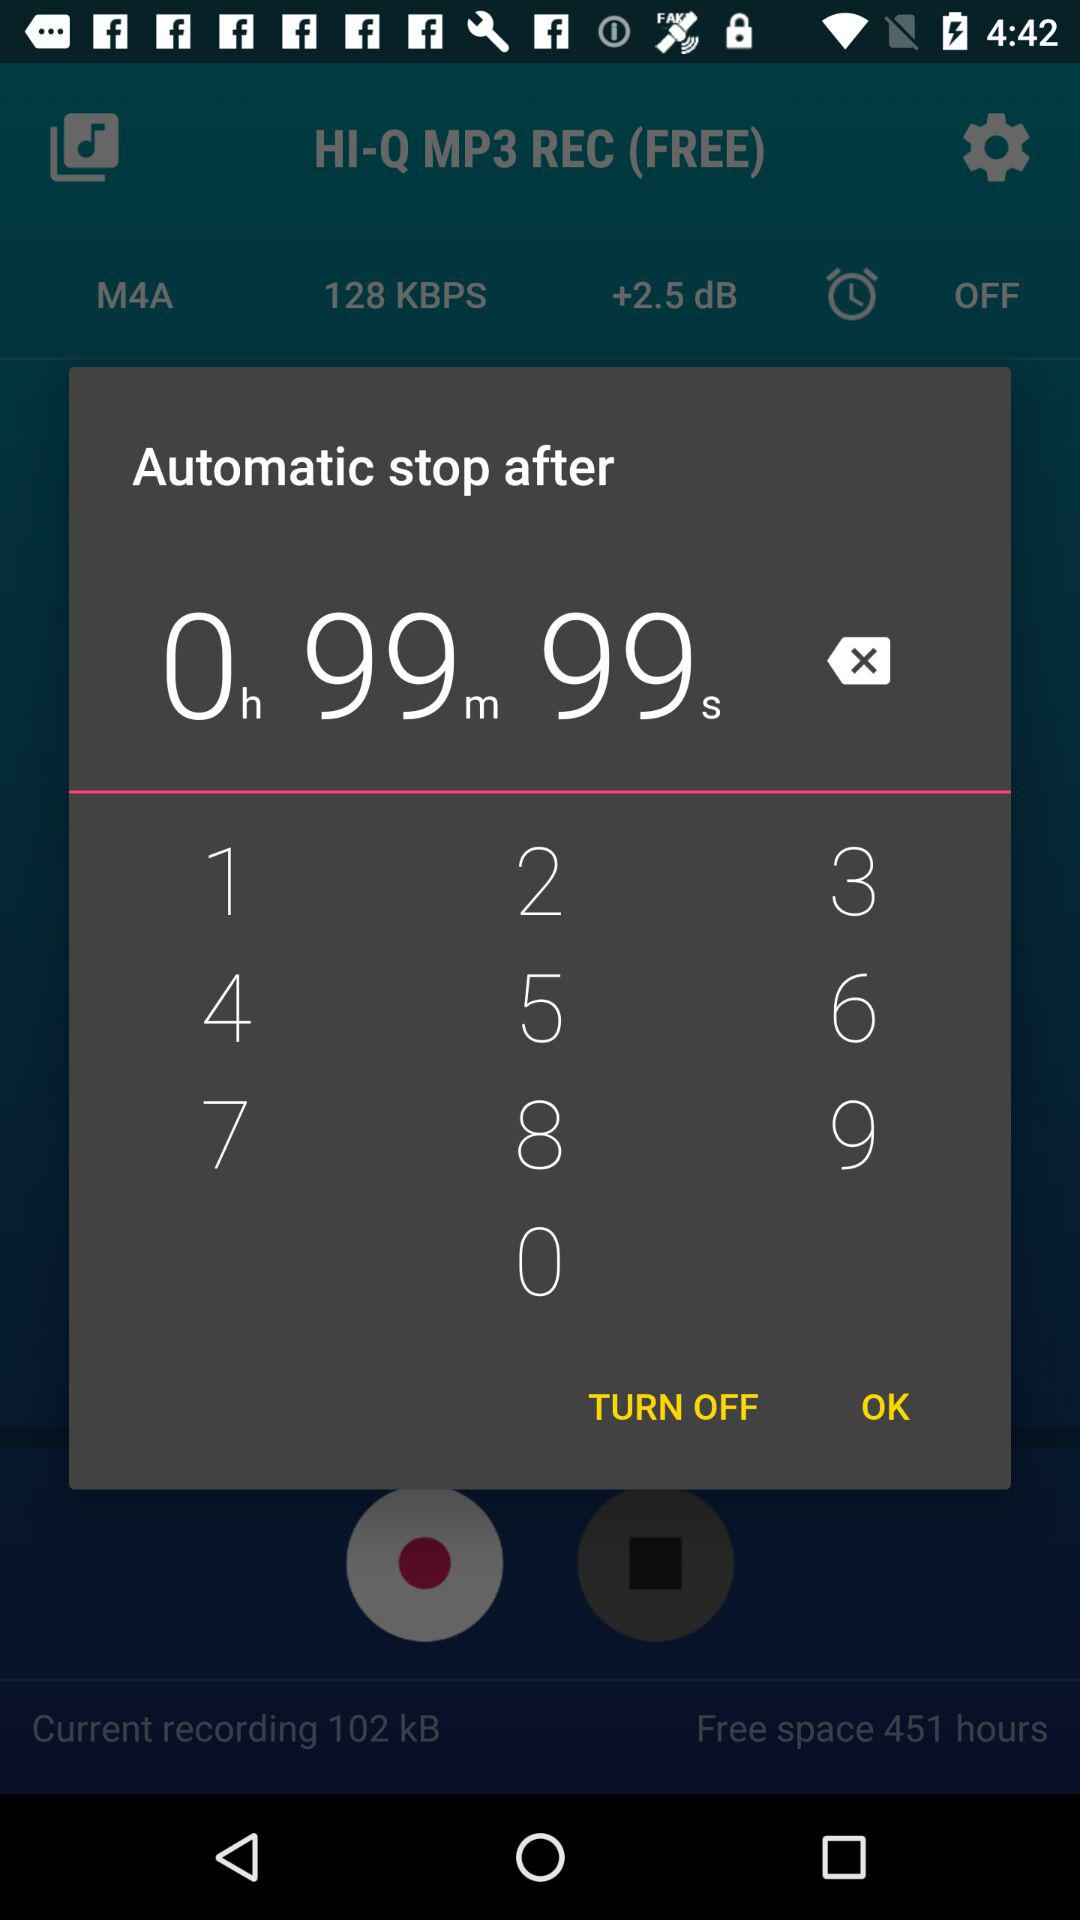What is the size of the current recording in kB? The size of the current recording is 102 kB. 